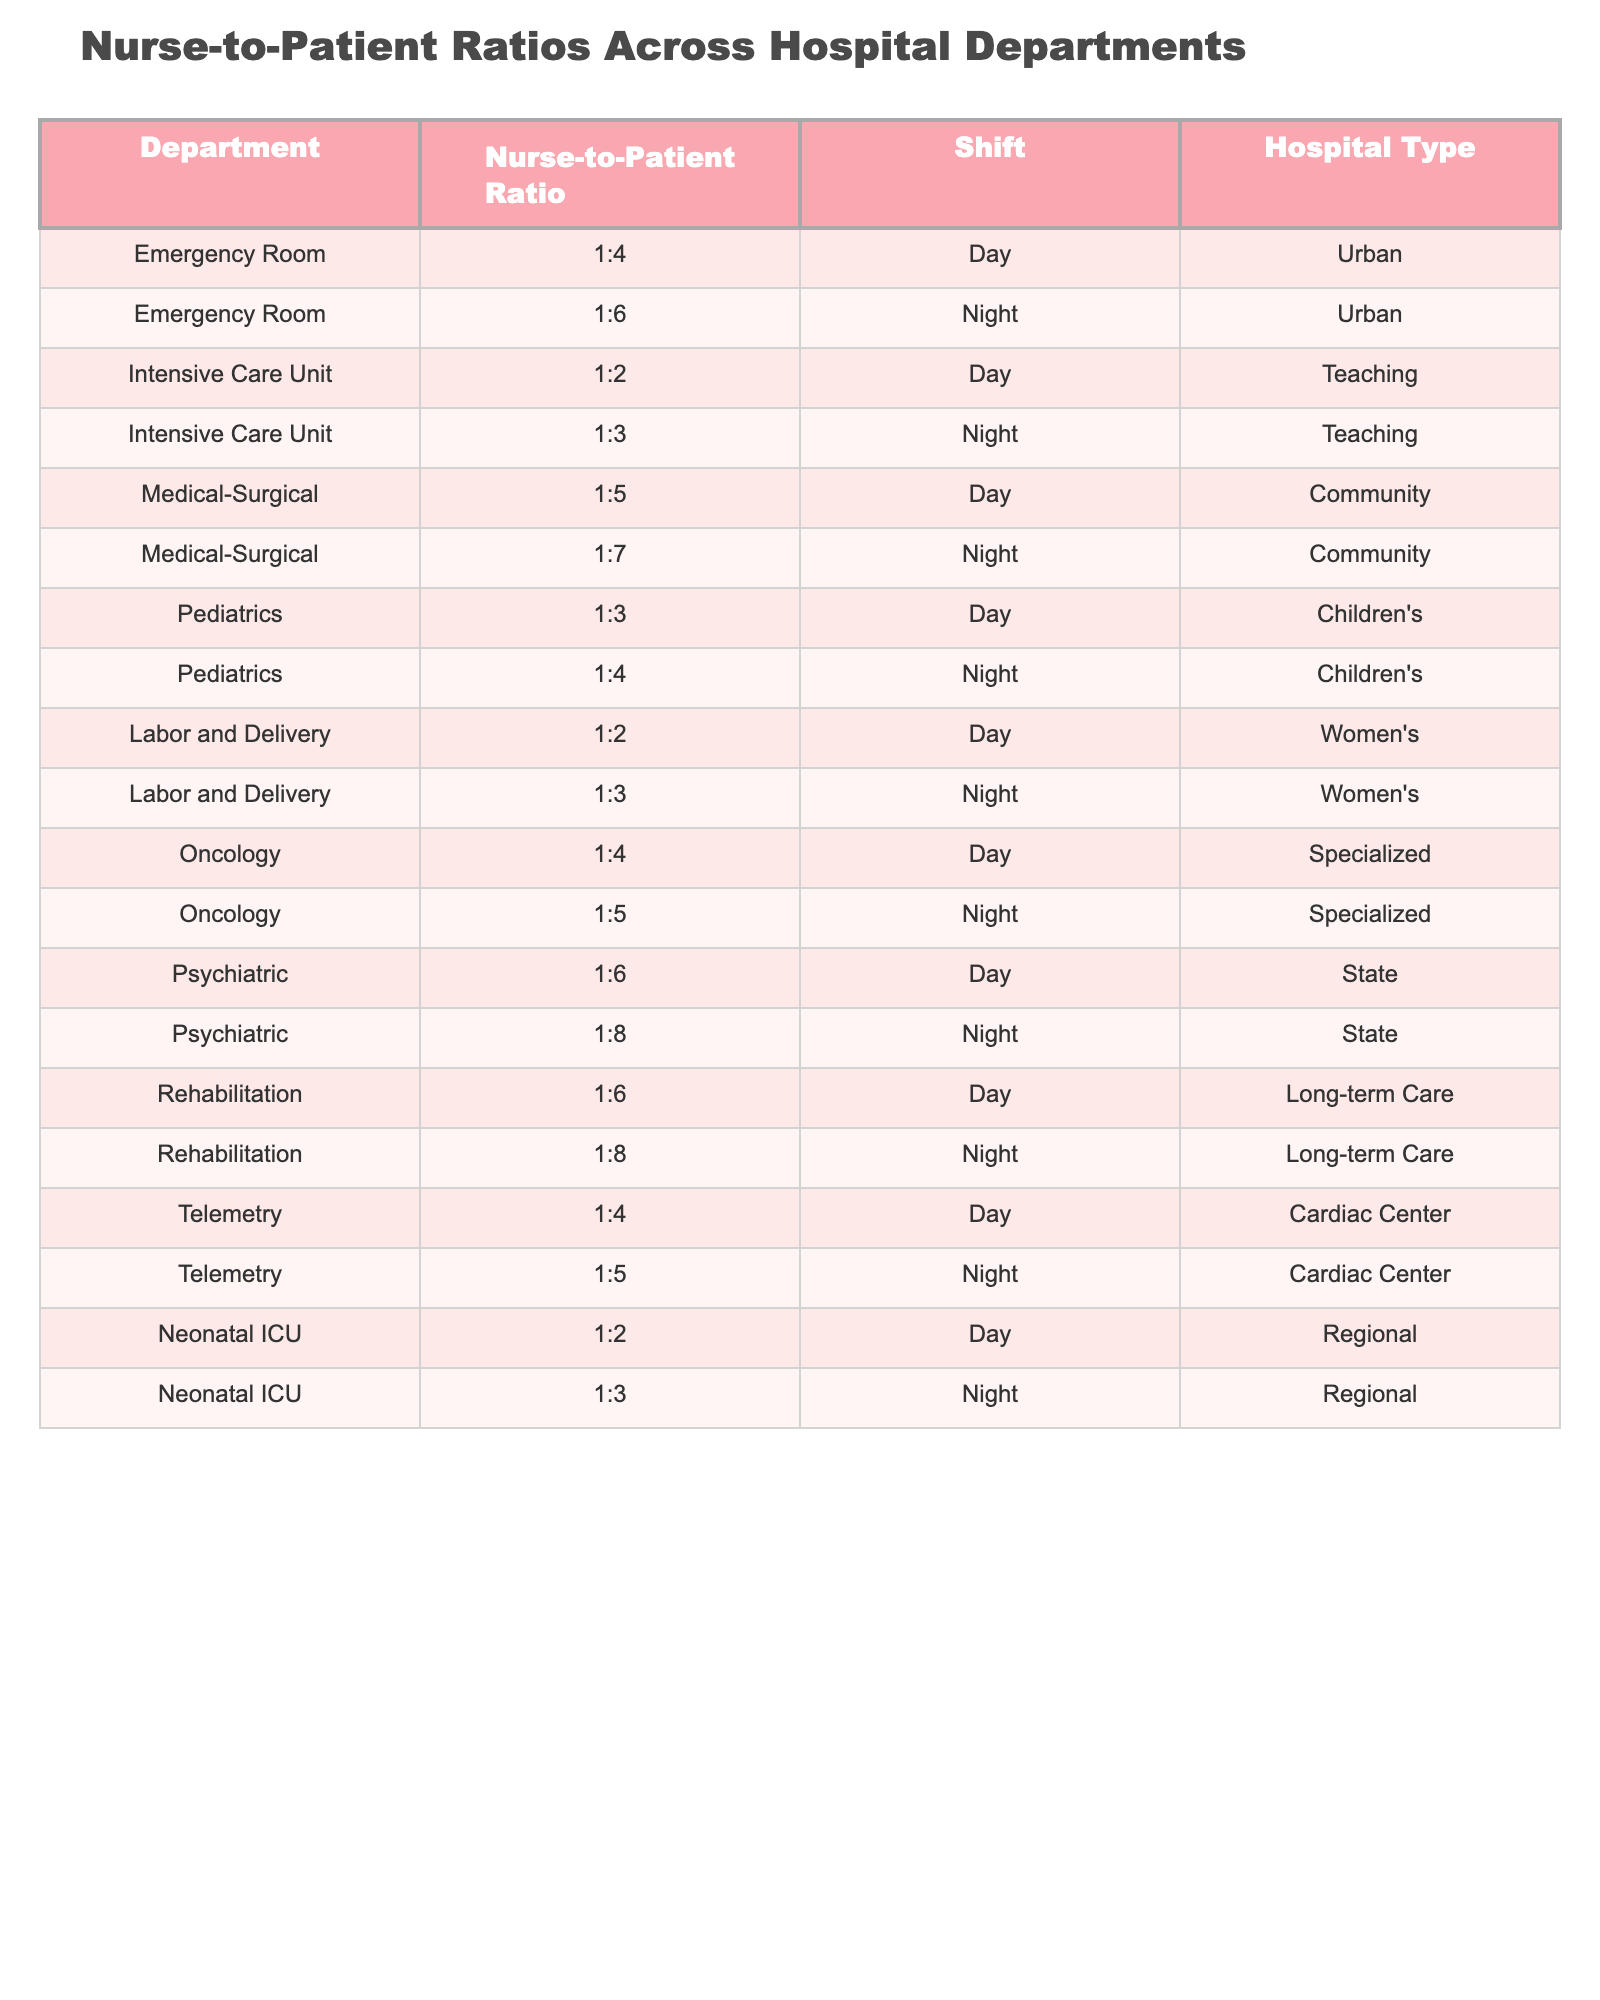What is the Nurse-to-Patient Ratio in the Emergency Room during the Day shift? The table provides the Nurse-to-Patient Ratio for the Emergency Room during the Day shift as 1:4.
Answer: 1:4 What is the Nurse-to-Patient Ratio for the Intensive Care Unit at Night? According to the table, the Night Nurse-to-Patient Ratio for the Intensive Care Unit is 1:3.
Answer: 1:3 How many different Nurse-to-Patient Ratios are listed for the Medical-Surgical department? The table shows two Nurse-to-Patient Ratios for the Medical-Surgical department, one for Day shift (1:5) and one for Night shift (1:7).
Answer: 2 Is the Nurse-to-Patient Ratio for Labor and Delivery higher at Night compared to Day? The Night ratio for Labor and Delivery is 1:3, while the Day ratio is 1:2; thus, the Night ratio (1:3) is higher than the Day ratio (1:2).
Answer: Yes What is the average Nurse-to-Patient Ratio for the Oncology department across both shifts? The Day ratio is 1:4 and the Night ratio is 1:5, which can be represented as fractions (0.25 and 0.20 respectively). Adding these: 0.25 + 0.20 = 0.45. Dividing by 2 gives an average ratio of 0.225. Reverting this back to ratio form gives an average of approximately 1:4.44.
Answer: 1:4.44 Is there a department where the Nurse-to-Patient Ratio is the same during both Day and Night shifts? Reviewing the table shows that the Nurse-to-Patient Ratios vary among departments; no department has the same ratio for both shifts.
Answer: No How does the Nurse-to-Patient Ratio in the Telemetry department at Night compare to that in the Emergency Room during the Day? The Night ratio for Telemetry is 1:5 while the Day ratio for Emergency Room is 1:4. The Telemetry ratio (1:5) is worse than the Emergency Room’s Day ratio (1:4).
Answer: 1:5 is worse What is the total number of hospital departments listed in the table? Counting each unique department, there are 10 different hospital departments represented in the table.
Answer: 10 Which department has the best (lowest) Nurse-to-Patient Ratio during the Day shift? The Intensive Care Unit has the best Nurse-to-Patient Ratio during the Day shift at 1:2, as it provides more nurses per patient compared to others listed for the Day shift.
Answer: Intensive Care Unit (1:2) What is the ratio with the largest number of patients per nurse during the Night shift? The Psychiatric department has the highest ratio of 1:8 during the Night shift, indicating that one nurse is assigned to eight patients.
Answer: 1:8 